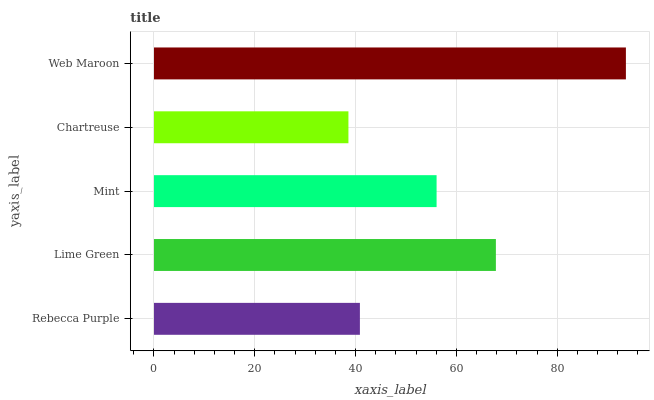Is Chartreuse the minimum?
Answer yes or no. Yes. Is Web Maroon the maximum?
Answer yes or no. Yes. Is Lime Green the minimum?
Answer yes or no. No. Is Lime Green the maximum?
Answer yes or no. No. Is Lime Green greater than Rebecca Purple?
Answer yes or no. Yes. Is Rebecca Purple less than Lime Green?
Answer yes or no. Yes. Is Rebecca Purple greater than Lime Green?
Answer yes or no. No. Is Lime Green less than Rebecca Purple?
Answer yes or no. No. Is Mint the high median?
Answer yes or no. Yes. Is Mint the low median?
Answer yes or no. Yes. Is Rebecca Purple the high median?
Answer yes or no. No. Is Rebecca Purple the low median?
Answer yes or no. No. 